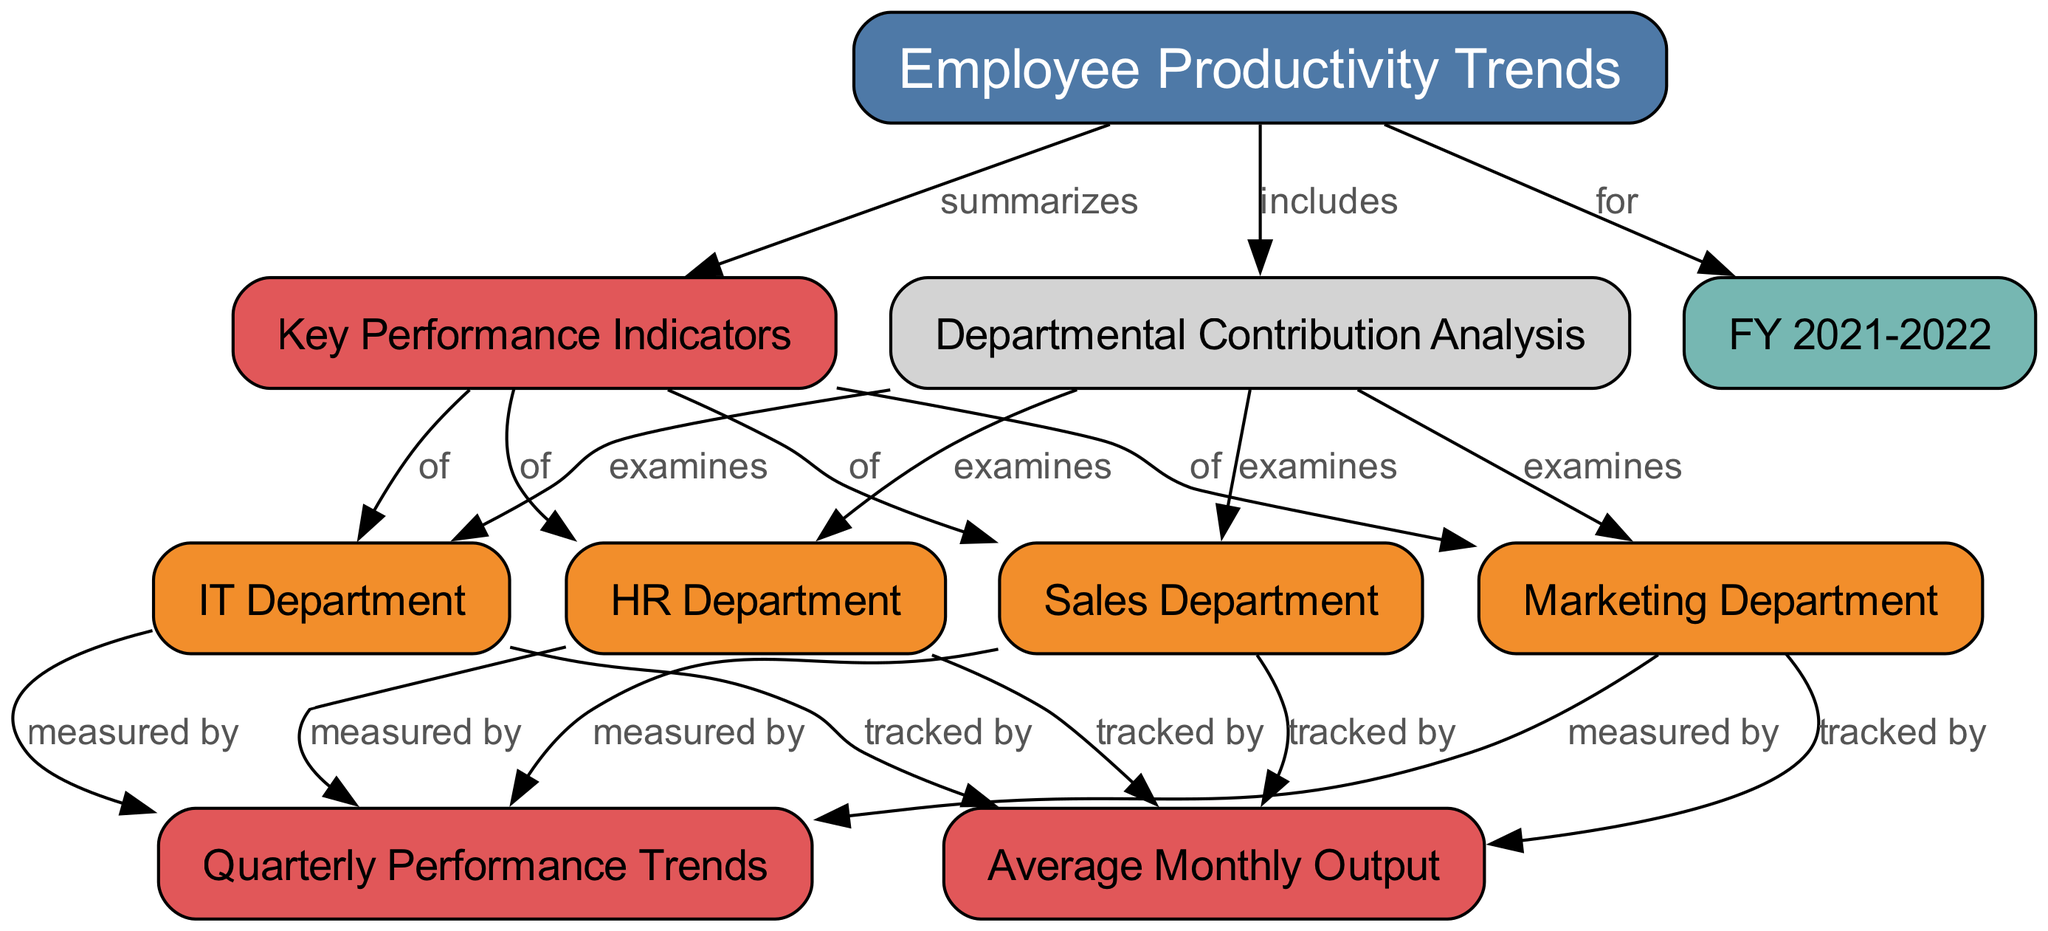What is the main topic of the diagram? The label on the main node states "Employee Productivity Trends," which indicates that it is the overarching topic of the diagram.
Answer: Employee Productivity Trends How many departments are examined in the Departmental Contribution Analysis? The diagram shows four departments connected to the "Departmental Contribution Analysis" node: Sales, Marketing, IT, and HR, which totals to four departments.
Answer: Four Which metric tracks the departments' contributions? All four departments point to the "Average Monthly Output" node, indicating that this metric is used to track their contributions.
Answer: Average Monthly Output What do the quarterly performance trends measure? Each department is connected to the "Quarterly Performance Trends" node, which indicates that these trends measure performance across all departments.
Answer: Performance What does the diagram summarize about the key performance indicators? The "Employee Productivity Trends" node summarizes the four departments' key performance indicators as indicated by the edges leading to the "Key Performance Indicators" node.
Answer: Key Performance Indicators Which department is linked to the metrics tracked by the diagram? Each of the four departments is linked to the "Average Monthly Output," showing that they each have productivity metrics tracked by this metric.
Answer: Each department What relationship do the "Sales Department" and "Quarterly Performance Trends" have? The "Sales Department" is connected to the "Quarterly Performance Trends" entry, indicating that quarterly performance is measured by the output of the Sales Department.
Answer: Measured by In what time frame is the productivity trend analyzed? The node labeled "FY 2021-2022" identifies the specific fiscal year during which the productivity trends are analyzed.
Answer: FY 2021-2022 How does the diagram categorize information related to the major departments? The departments are categorized as nodes with the label "examines" to indicate that the diagram looks into the contributions of each department.
Answer: Examines 